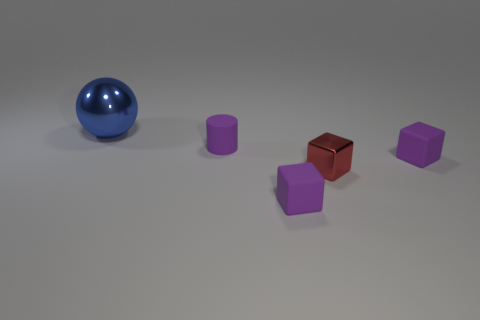Subtract all tiny matte cubes. How many cubes are left? 1 Add 5 tiny metallic objects. How many objects exist? 10 Subtract all red blocks. How many blocks are left? 2 Subtract all cubes. How many objects are left? 2 Subtract all yellow spheres. How many blue blocks are left? 0 Subtract 2 cubes. How many cubes are left? 1 Subtract all green cylinders. Subtract all yellow blocks. How many cylinders are left? 1 Subtract all small purple matte cylinders. Subtract all big blue things. How many objects are left? 3 Add 5 small purple cylinders. How many small purple cylinders are left? 6 Add 1 balls. How many balls exist? 2 